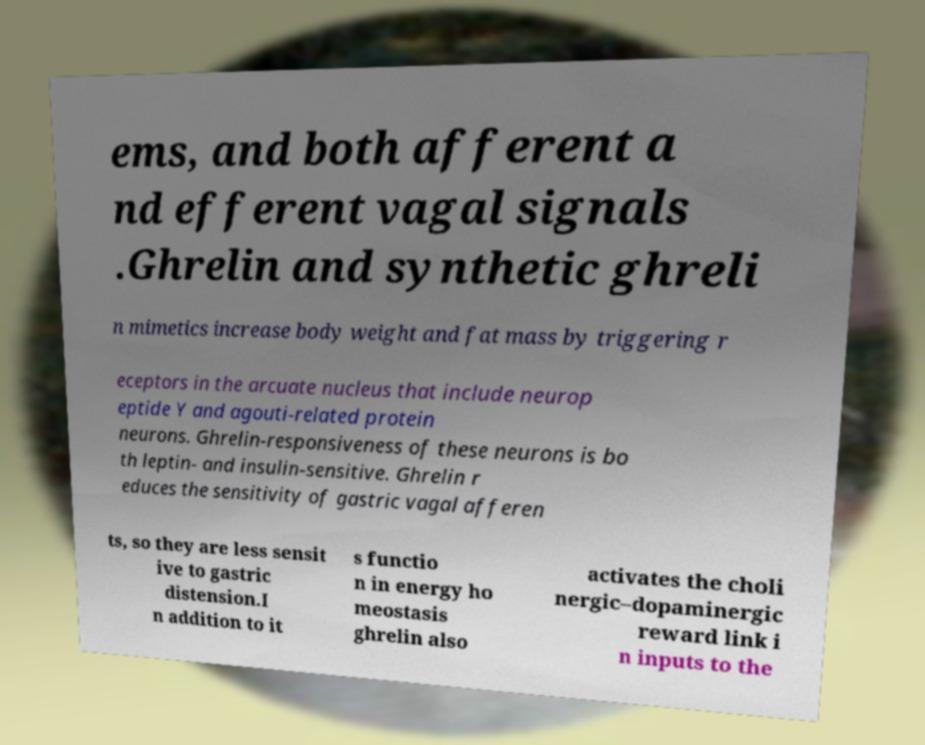Please read and relay the text visible in this image. What does it say? ems, and both afferent a nd efferent vagal signals .Ghrelin and synthetic ghreli n mimetics increase body weight and fat mass by triggering r eceptors in the arcuate nucleus that include neurop eptide Y and agouti-related protein neurons. Ghrelin-responsiveness of these neurons is bo th leptin- and insulin-sensitive. Ghrelin r educes the sensitivity of gastric vagal afferen ts, so they are less sensit ive to gastric distension.I n addition to it s functio n in energy ho meostasis ghrelin also activates the choli nergic–dopaminergic reward link i n inputs to the 